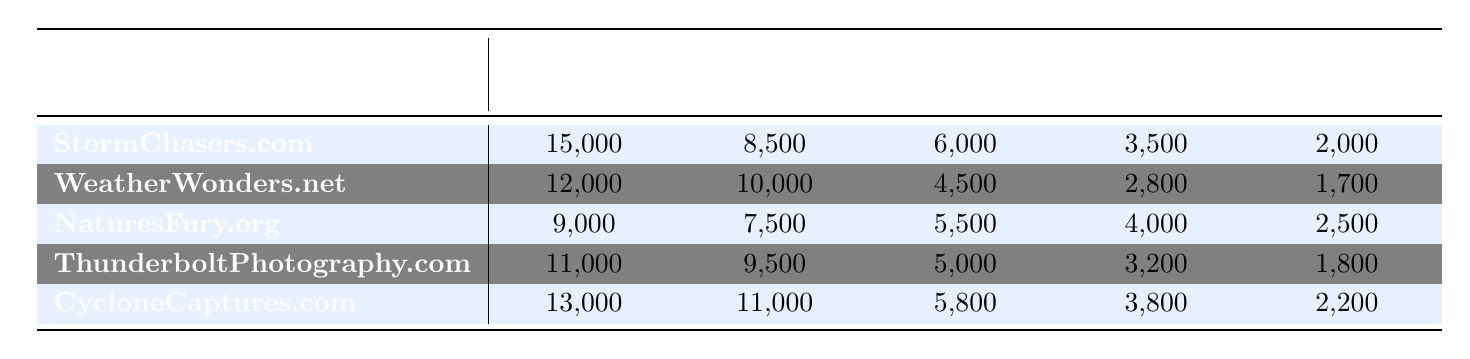What is the website with the highest traffic from Organic Search? Looking at the "Organic Search" column, the highest value is 15,000, which corresponds to StormChasers.com.
Answer: StormChasers.com Which website received the least traffic from Email Marketing? In the "Email Marketing" column, the lowest value is 1,700, which is associated with WeatherWonders.net.
Answer: WeatherWonders.net How many total visits came from Social Media across all websites? To find the total, add the values from the Social Media column: 8,500 + 10,000 + 7,500 + 9,500 + 11,000 = 46,500.
Answer: 46,500 Which traffic source brought in more visitors to NaturesFury.org, Direct or Referral? For NaturesFury.org, Direct had 5,500 visitors and Referral had 4,000. Since 5,500 is greater than 4,000, Direct brought in more visitors.
Answer: Direct What is the average traffic from Organic Search across all websites? To calculate the average, sum the Organic Search values: 15,000 + 12,000 + 9,000 + 11,000 + 13,000 = 60,000; then divide by 5 (the number of websites): 60,000 / 5 = 12,000.
Answer: 12,000 Which website had more traffic from Direct than ThunderboltPhotography.com? ThunderboltPhotography.com received 5,000 from Direct. Comparing other websites, only WeatherWonders.net (4,500) and NaturesFury.org (5,500) have lower numbers; CycloneCaptures.com (5,800) has more, thus the websites with more traffic from Direct than ThunderboltPhotography.com is CycloneCaptures.com and NaturesFury.org.
Answer: CycloneCaptures.com, NaturesFury.org What is the total traffic from all sources for CycloneCaptures.com? For CycloneCaptures.com, sum all the traffic sources: 13,000 (Organic Search) + 11,000 (Social Media) + 5,800 (Direct) + 3,800 (Referral) + 2,200 (Email Marketing) = 35,800.
Answer: 35,800 Which traffic source accounts for the most visitors on WeatherWonders.net? By examining the website, Social Media has the highest value of 10,000 compared to the other sources listed.
Answer: Social Media 